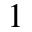Convert formula to latex. <formula><loc_0><loc_0><loc_500><loc_500>^ { 1 }</formula> 